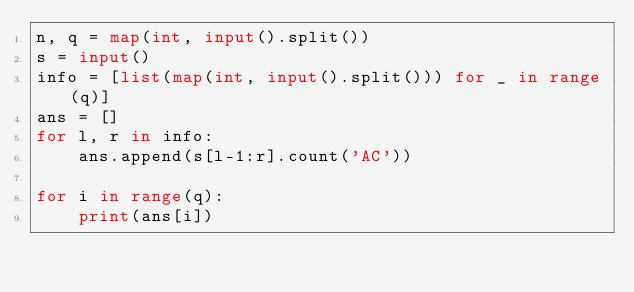Convert code to text. <code><loc_0><loc_0><loc_500><loc_500><_Python_>n, q = map(int, input().split())
s = input()
info = [list(map(int, input().split())) for _ in range(q)]
ans = []
for l, r in info:
    ans.append(s[l-1:r].count('AC'))

for i in range(q):
    print(ans[i])</code> 